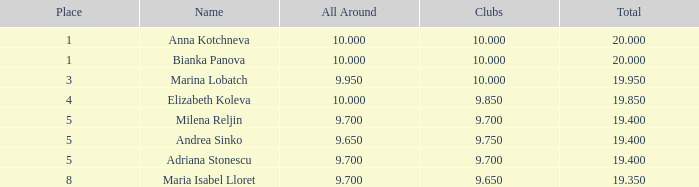What aggregate has 10 as the associations, with a rank more than 1? 19.95. 